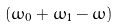<formula> <loc_0><loc_0><loc_500><loc_500>( \omega _ { 0 } + \omega _ { 1 } - \omega )</formula> 